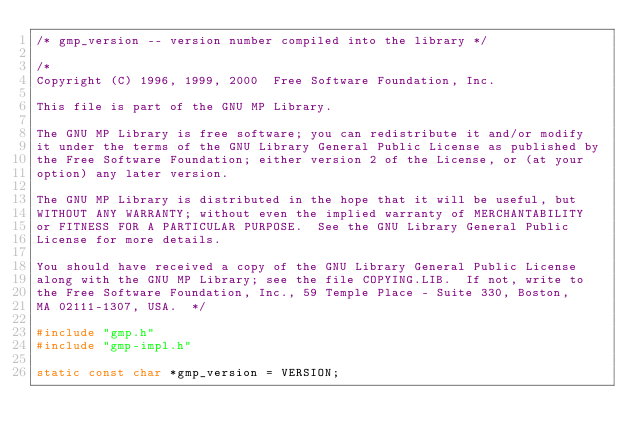<code> <loc_0><loc_0><loc_500><loc_500><_C_>/* gmp_version -- version number compiled into the library */

/*
Copyright (C) 1996, 1999, 2000  Free Software Foundation, Inc.

This file is part of the GNU MP Library.

The GNU MP Library is free software; you can redistribute it and/or modify
it under the terms of the GNU Library General Public License as published by
the Free Software Foundation; either version 2 of the License, or (at your
option) any later version.

The GNU MP Library is distributed in the hope that it will be useful, but
WITHOUT ANY WARRANTY; without even the implied warranty of MERCHANTABILITY
or FITNESS FOR A PARTICULAR PURPOSE.  See the GNU Library General Public
License for more details.

You should have received a copy of the GNU Library General Public License
along with the GNU MP Library; see the file COPYING.LIB.  If not, write to
the Free Software Foundation, Inc., 59 Temple Place - Suite 330, Boston,
MA 02111-1307, USA.  */

#include "gmp.h"
#include "gmp-impl.h"

static const char *gmp_version = VERSION;
</code> 